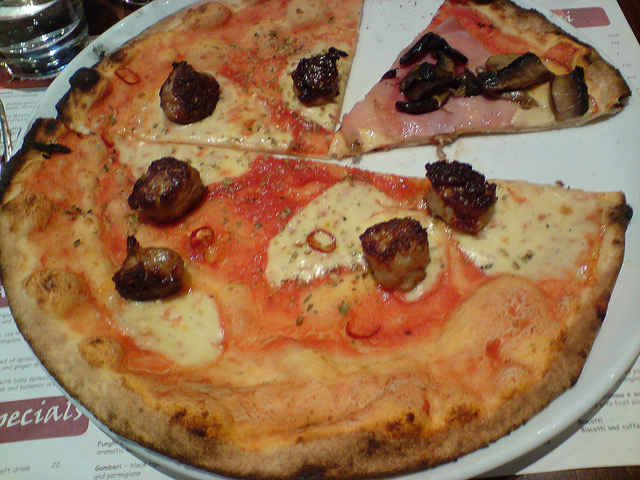Identify the text displayed in this image. pecial 